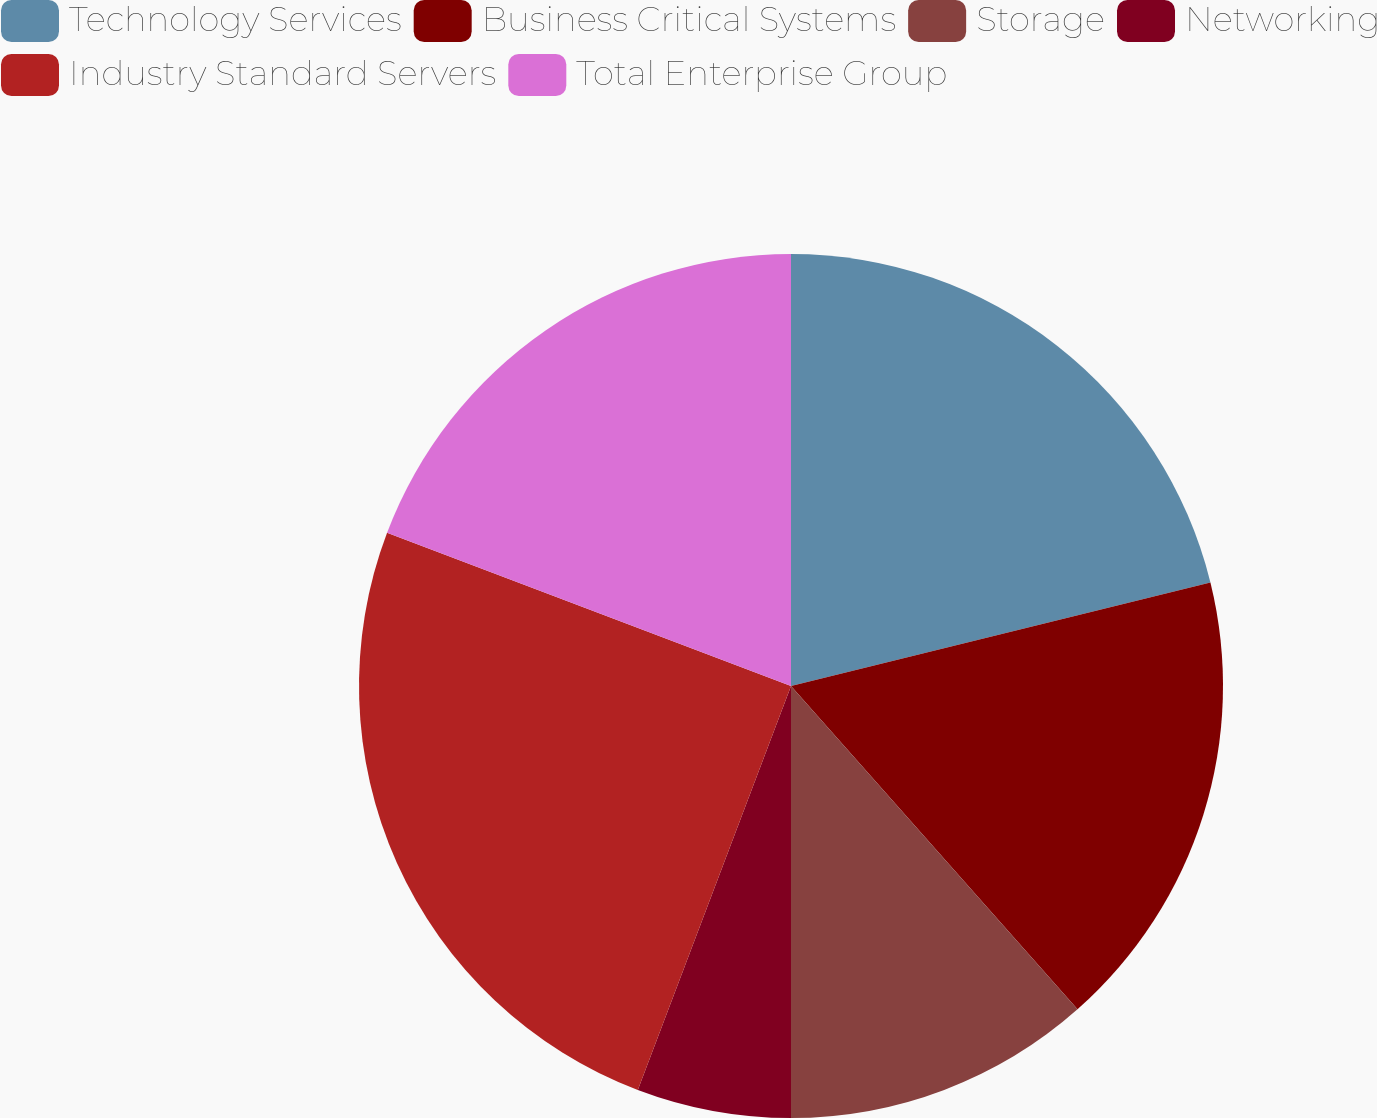Convert chart to OTSL. <chart><loc_0><loc_0><loc_500><loc_500><pie_chart><fcel>Technology Services<fcel>Business Critical Systems<fcel>Storage<fcel>Networking<fcel>Industry Standard Servers<fcel>Total Enterprise Group<nl><fcel>21.15%<fcel>17.31%<fcel>11.54%<fcel>5.77%<fcel>25.0%<fcel>19.23%<nl></chart> 